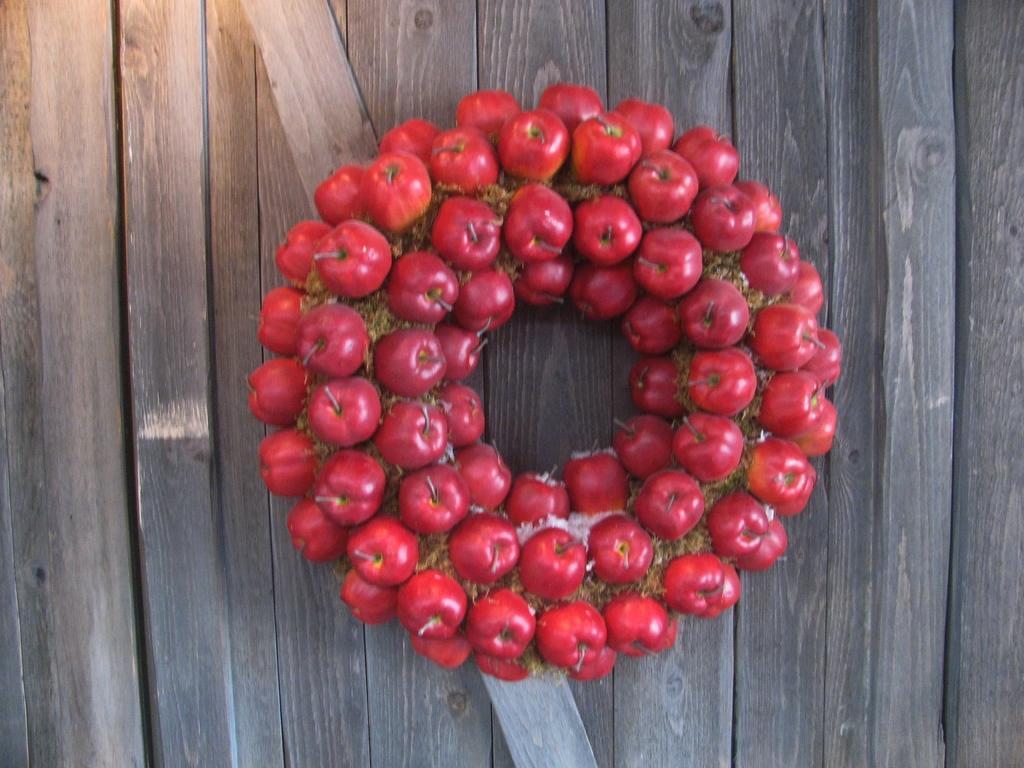Describe this image in one or two sentences. In this picture I can see the berries which are in the center and they're on the wooden surface. 